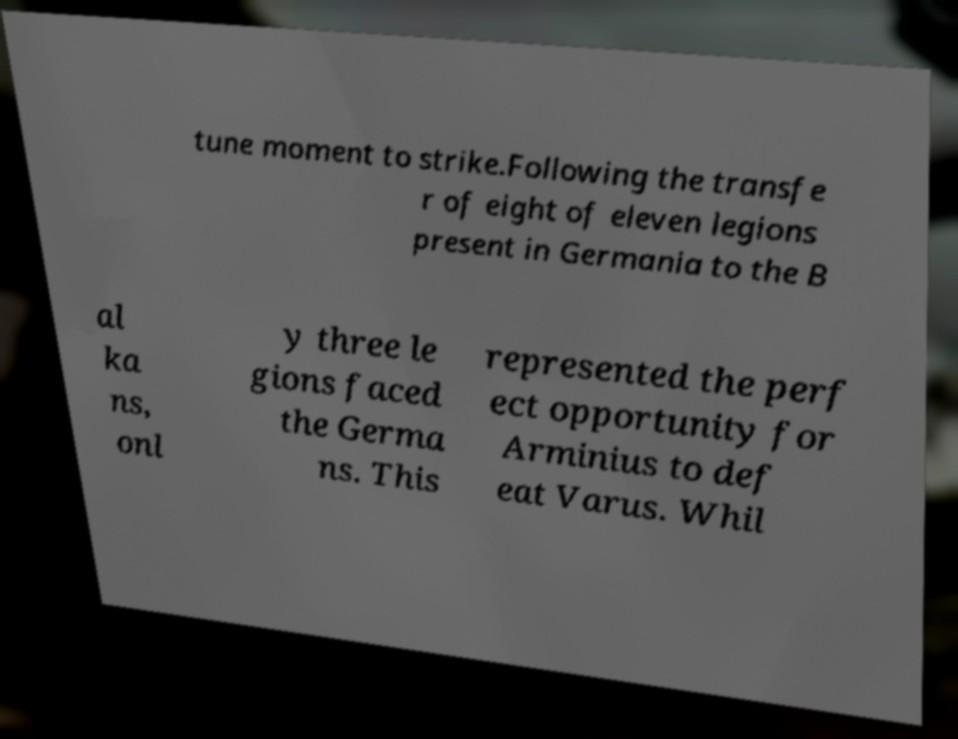There's text embedded in this image that I need extracted. Can you transcribe it verbatim? tune moment to strike.Following the transfe r of eight of eleven legions present in Germania to the B al ka ns, onl y three le gions faced the Germa ns. This represented the perf ect opportunity for Arminius to def eat Varus. Whil 